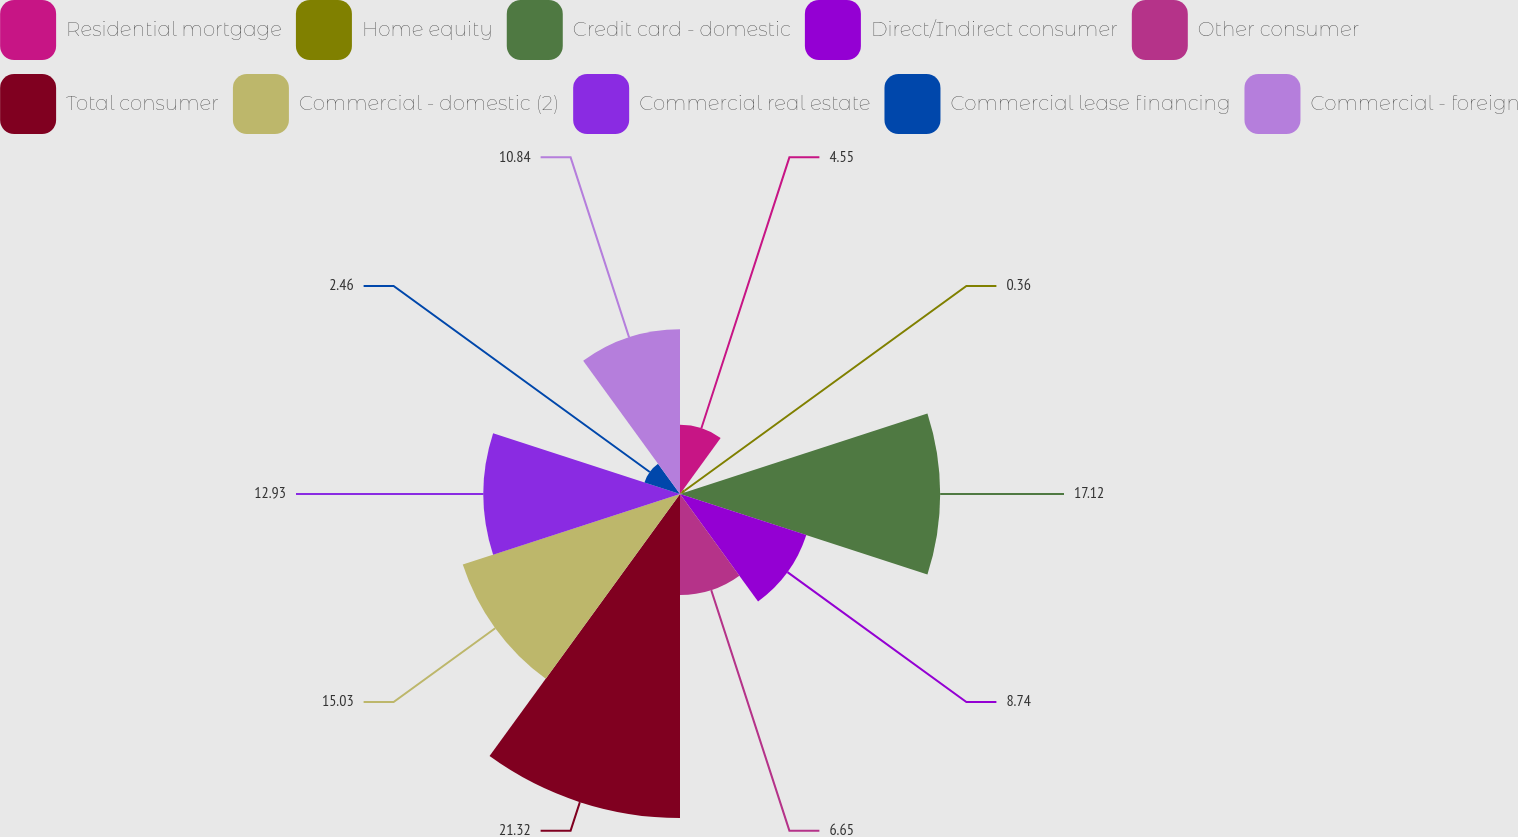Convert chart. <chart><loc_0><loc_0><loc_500><loc_500><pie_chart><fcel>Residential mortgage<fcel>Home equity<fcel>Credit card - domestic<fcel>Direct/Indirect consumer<fcel>Other consumer<fcel>Total consumer<fcel>Commercial - domestic (2)<fcel>Commercial real estate<fcel>Commercial lease financing<fcel>Commercial - foreign<nl><fcel>4.55%<fcel>0.36%<fcel>17.12%<fcel>8.74%<fcel>6.65%<fcel>21.32%<fcel>15.03%<fcel>12.93%<fcel>2.46%<fcel>10.84%<nl></chart> 